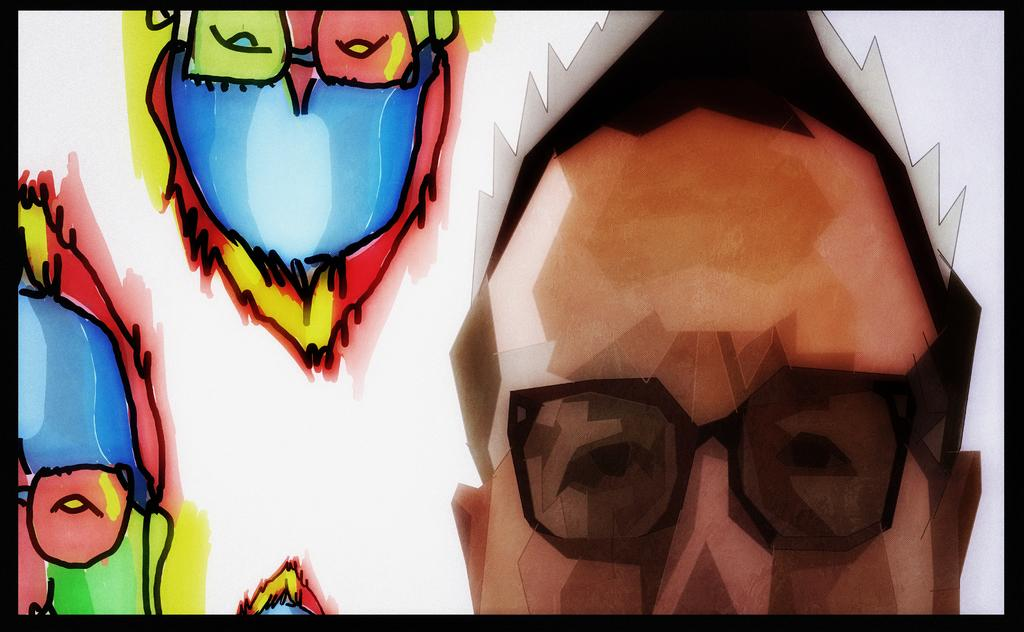What is the main subject of the poster in the image? The main subject of the poster in the image is a person's cartoon face wearing spectacles. Where is the person's cartoon face located on the poster? The person's cartoon face is on the right side of the poster. What is the person wearing on the poster? The person is wearing spectacles on the poster. Are there any other designs or elements on the poster besides the person's face? Yes, on the left side of the poster, there are designs of the same person. How does the pancake guide the person on the poster? There is no pancake present on the poster, so it cannot guide the person. 